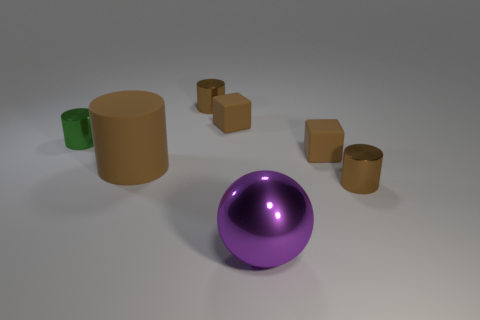Subtract all yellow spheres. How many brown cylinders are left? 3 Subtract all green cylinders. Subtract all green spheres. How many cylinders are left? 3 Add 2 yellow metallic blocks. How many objects exist? 9 Subtract all blocks. How many objects are left? 5 Subtract all large shiny balls. Subtract all large brown metallic balls. How many objects are left? 6 Add 6 brown rubber blocks. How many brown rubber blocks are left? 8 Add 7 yellow cylinders. How many yellow cylinders exist? 7 Subtract 0 gray blocks. How many objects are left? 7 